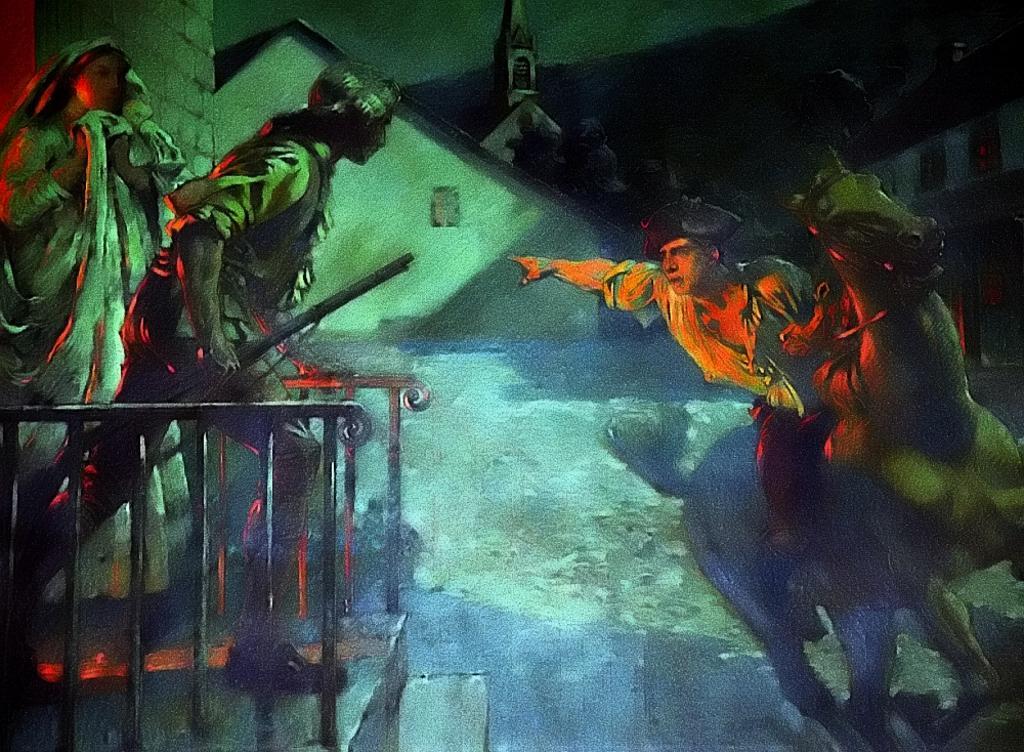Describe this image in one or two sentences. In this image I can see the painting in which I can see few stairs, the railing, few persons standing and a person sitting on a horse. In the background I can see few buildings and the sky. 